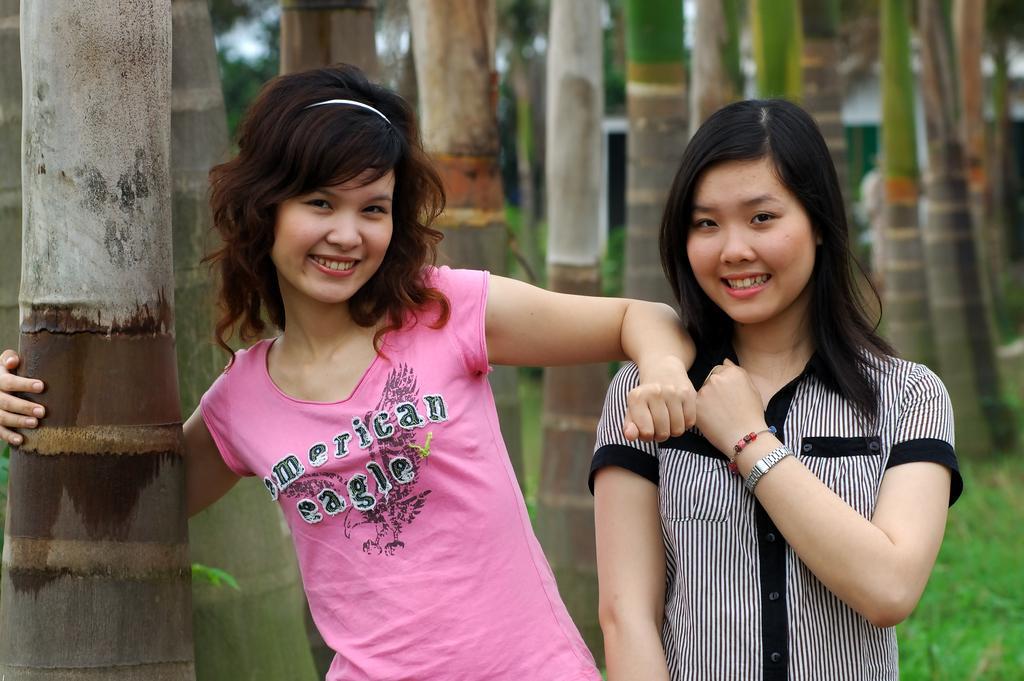Please provide a concise description of this image. In this image I can see two women are standing in the front and I can also see smile on their faces. I can also see number of trees and on the bottom right side of this image I can see grass. I can also see this image is little bit blurry in the background. 